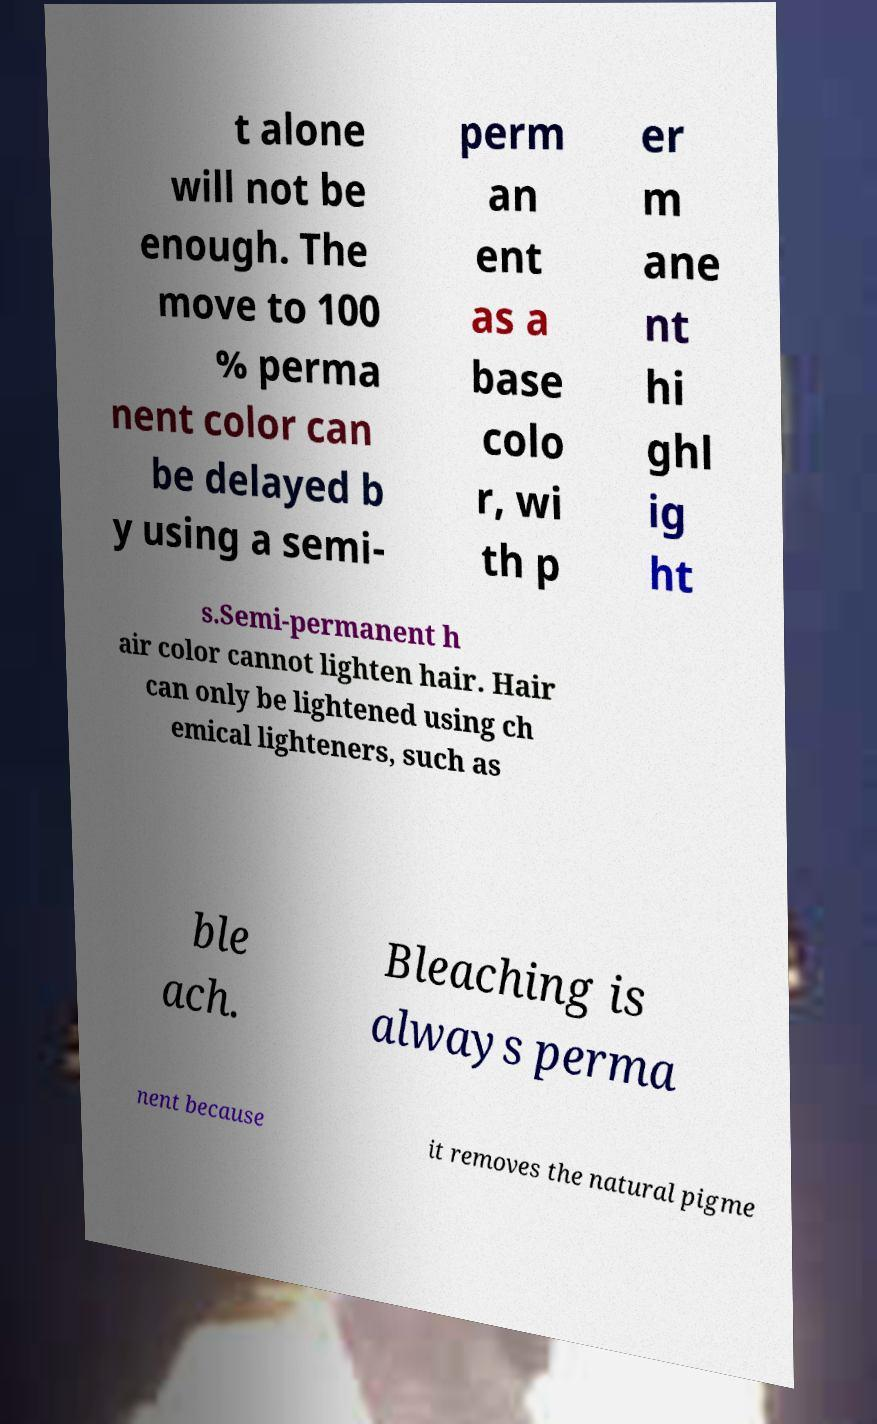Can you accurately transcribe the text from the provided image for me? t alone will not be enough. The move to 100 % perma nent color can be delayed b y using a semi- perm an ent as a base colo r, wi th p er m ane nt hi ghl ig ht s.Semi-permanent h air color cannot lighten hair. Hair can only be lightened using ch emical lighteners, such as ble ach. Bleaching is always perma nent because it removes the natural pigme 